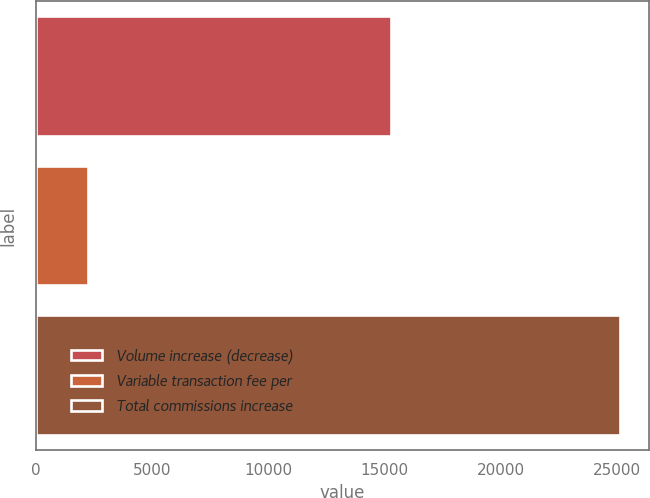Convert chart to OTSL. <chart><loc_0><loc_0><loc_500><loc_500><bar_chart><fcel>Volume increase (decrease)<fcel>Variable transaction fee per<fcel>Total commissions increase<nl><fcel>15259<fcel>2237<fcel>25135<nl></chart> 